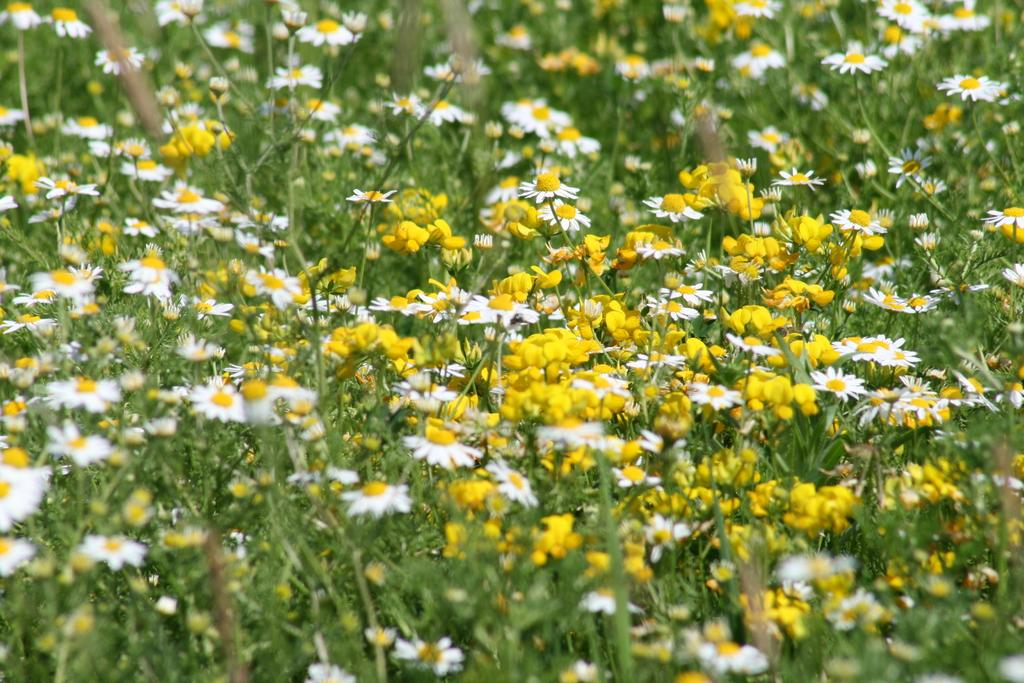What type of living organisms are present in the image? There are plants in the image. What color are the flowers on the plants? The plants have yellow flowers and white flowers. What is the texture of the eggnog in the image? There is no eggnog present in the image; it features plants with yellow and white flowers. 